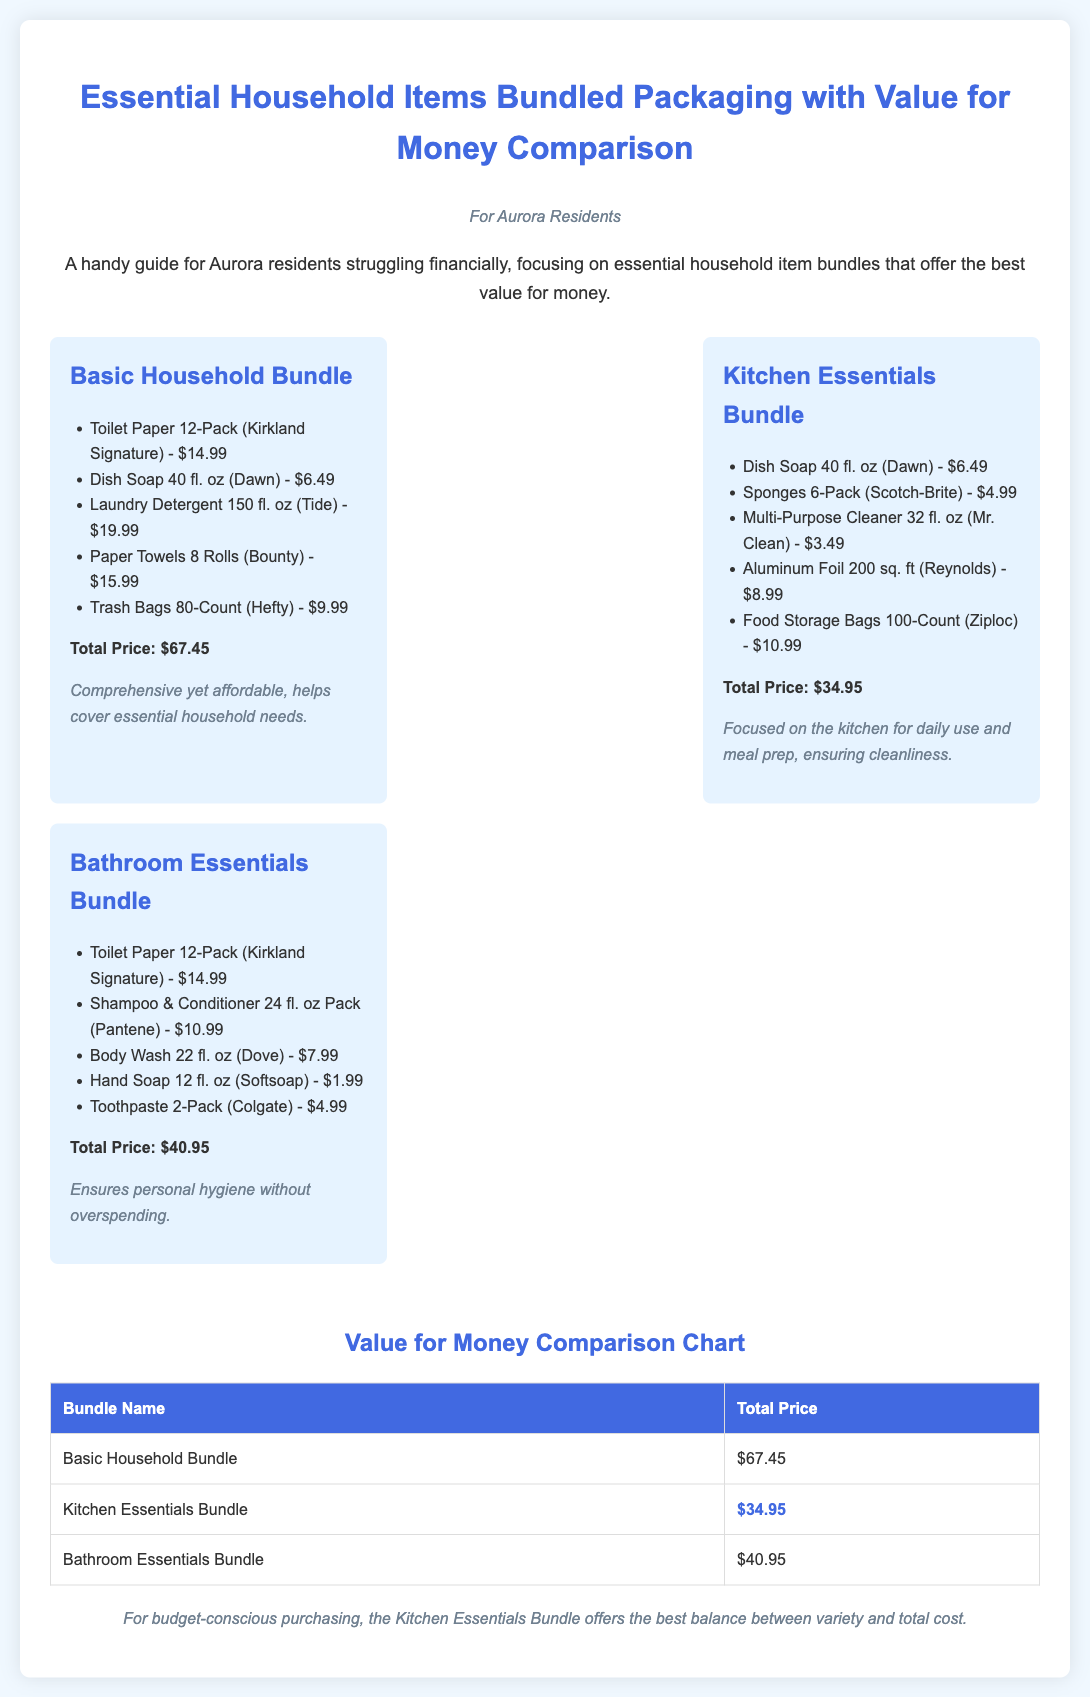what is the total price of the Basic Household Bundle? The total price is listed as $67.45 for the Basic Household Bundle.
Answer: $67.45 what does the Kitchen Essentials Bundle focus on? The description states that it focuses on the kitchen for daily use and meal prep.
Answer: the kitchen which bundle has the lowest total price? The Value for Money Comparison Chart shows that the Kitchen Essentials Bundle has the lowest total price at $34.95.
Answer: Kitchen Essentials Bundle how many items are in the Bathroom Essentials Bundle? The Bathroom Essentials Bundle lists five items.
Answer: five what is the total price of the Bathroom Essentials Bundle? The total price is given as $40.95 for the Bathroom Essentials Bundle.
Answer: $40.95 which product is included in both the Basic and Bathroom Essentials Bundles? The IoT is present in both bundles, specifically listed as Toilet Paper 12-Pack (Kirkland Signature).
Answer: Toilet Paper 12-Pack (Kirkland Signature) what is the total price for all items in the Kitchen Essentials Bundle? The total price is clearly stated as $34.95 for the Kitchen Essentials Bundle.
Answer: $34.95 which item in the Basic Household Bundle is the most expensive? The Laundry Detergent 150 fl. oz (Tide) is the most expensive at $19.99.
Answer: Laundry Detergent 150 fl. oz (Tide) what type of document is this? The headers, styles, and content indicate that this document is a product packaging guide.
Answer: product packaging guide 